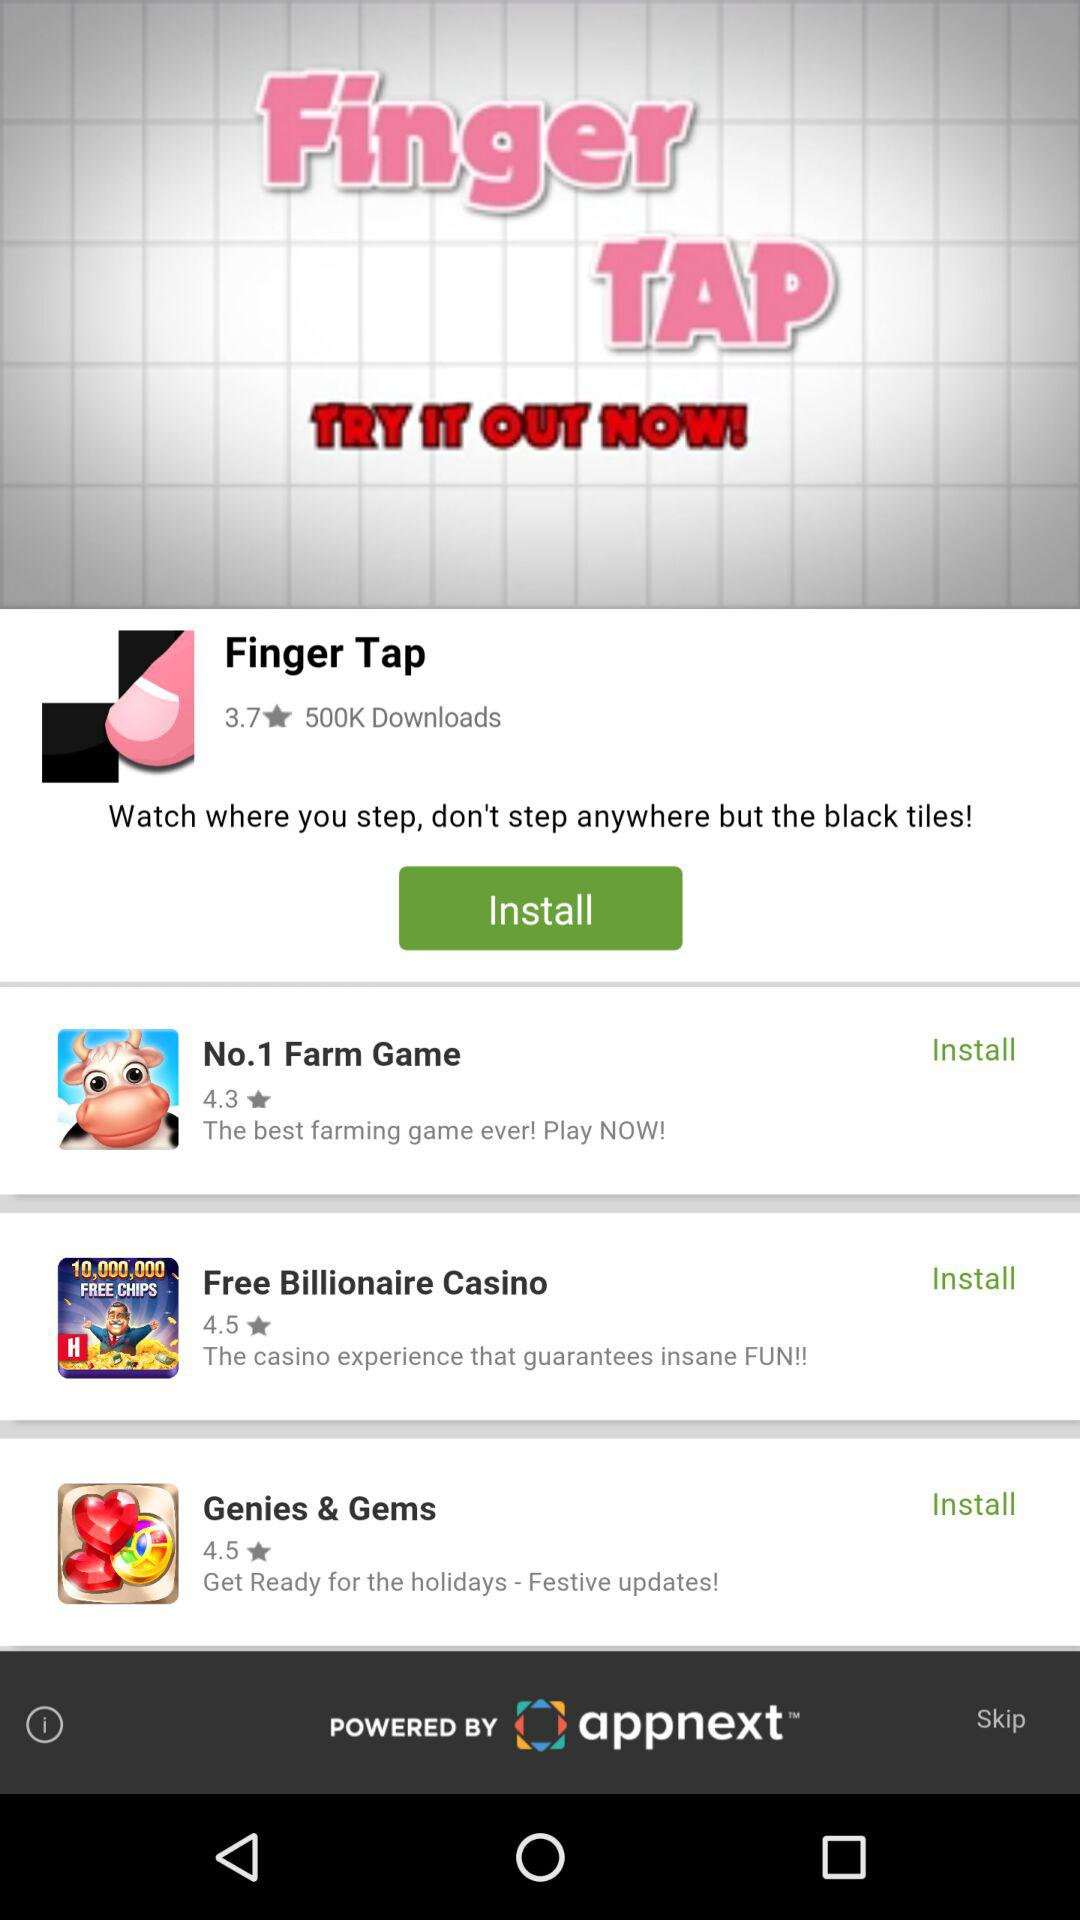What's the rating of "Free Billionaire Casino"? The rating is 4.5. 